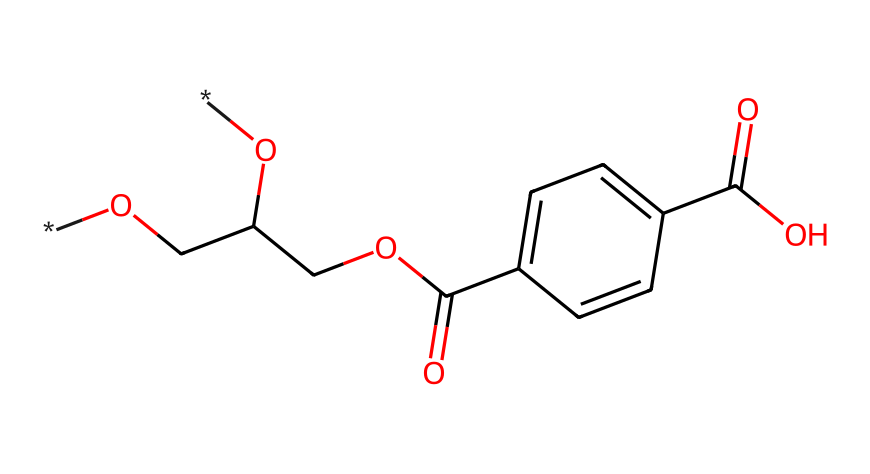What is the primary functional group present in the structure? The chemical structure contains an ester functional group, identifiable by the carbonyl (C=O) adjacent to an oxygen atom.
Answer: ester How many aromatic rings are present in the chemical structure? Examining the structure, there is one aromatic ring, which can be recognized by the six-carbon cyclic arrangement with alternating double bonds.
Answer: 1 What type of polymer does this structure represent? The presence of repeated ester linkages in the backbone indicates that this structure represents a polyester.
Answer: polyester How many hydroxyl (–OH) groups are present in the structure? By analyzing the structure, there are two hydroxyl groups, which can be identified by the –OH functional groups connected to carbon atoms.
Answer: 2 What is the total number of carbon (C) atoms in the structure? Counting the carbon atoms in the structure, I find a total of 12 carbon atoms present throughout the various functional groups and aromatic ring.
Answer: 12 What property of PET makes it suitable for pet food containers? The chemical structure shows that PET is durable and resistant to moisture, making it ideal for storing food products safely.
Answer: durability How does the presence of the aromatic ring influence the properties of PET? The aromatic ring contributes to the rigidity and thermal stability of PET, enhancing its strength and allowing it to maintain shape at elevated temperatures.
Answer: rigidity 